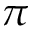Convert formula to latex. <formula><loc_0><loc_0><loc_500><loc_500>\pi</formula> 